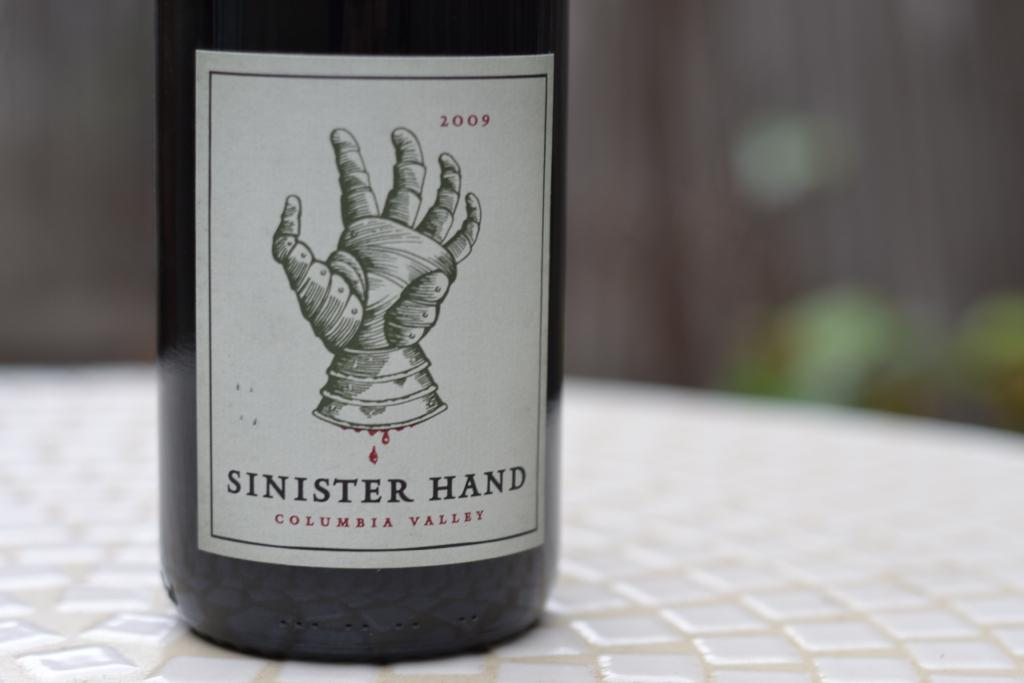What is on the bottle in the image? There is a label on the bottle. What is depicted on the label? The label has a picture of a hand. Are there any words on the label? Yes, there is text on the label. Where is the bottle located in the image? The bottle is on a table. What type of attraction can be seen in the image? There is no attraction present in the image; it features a bottle with a label on a table. How many snakes are visible in the image? There are no snakes present in the image. 